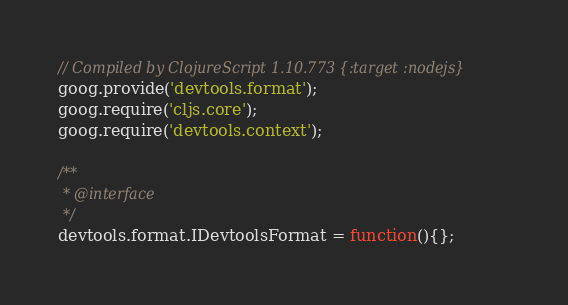Convert code to text. <code><loc_0><loc_0><loc_500><loc_500><_JavaScript_>// Compiled by ClojureScript 1.10.773 {:target :nodejs}
goog.provide('devtools.format');
goog.require('cljs.core');
goog.require('devtools.context');

/**
 * @interface
 */
devtools.format.IDevtoolsFormat = function(){};
</code> 